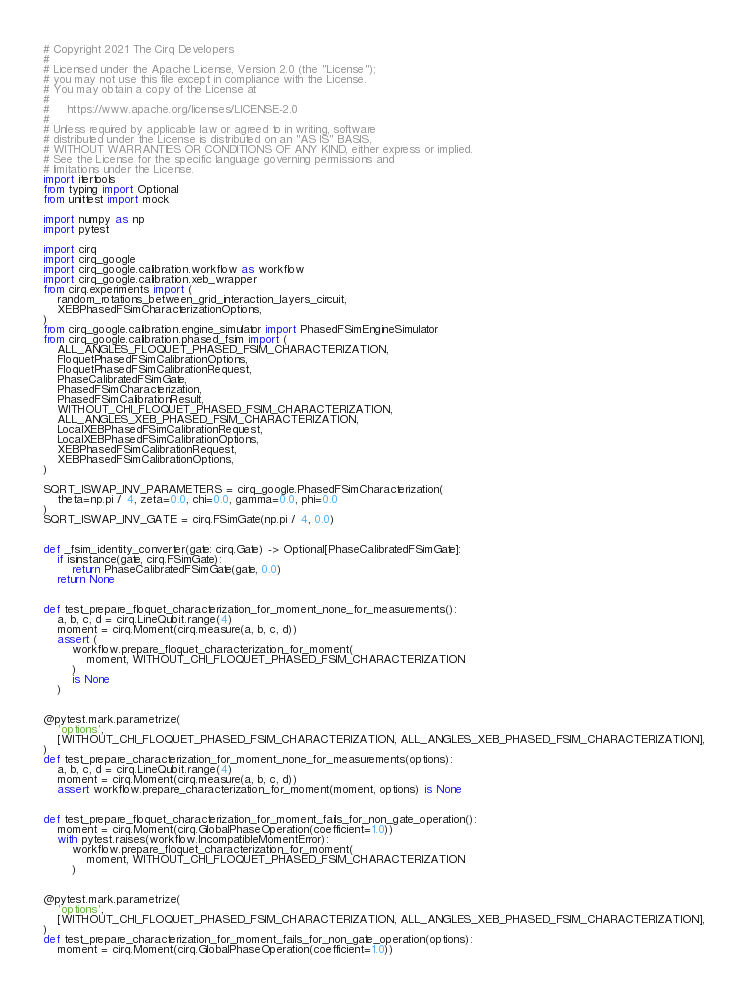Convert code to text. <code><loc_0><loc_0><loc_500><loc_500><_Python_># Copyright 2021 The Cirq Developers
#
# Licensed under the Apache License, Version 2.0 (the "License");
# you may not use this file except in compliance with the License.
# You may obtain a copy of the License at
#
#     https://www.apache.org/licenses/LICENSE-2.0
#
# Unless required by applicable law or agreed to in writing, software
# distributed under the License is distributed on an "AS IS" BASIS,
# WITHOUT WARRANTIES OR CONDITIONS OF ANY KIND, either express or implied.
# See the License for the specific language governing permissions and
# limitations under the License.
import itertools
from typing import Optional
from unittest import mock

import numpy as np
import pytest

import cirq
import cirq_google
import cirq_google.calibration.workflow as workflow
import cirq_google.calibration.xeb_wrapper
from cirq.experiments import (
    random_rotations_between_grid_interaction_layers_circuit,
    XEBPhasedFSimCharacterizationOptions,
)
from cirq_google.calibration.engine_simulator import PhasedFSimEngineSimulator
from cirq_google.calibration.phased_fsim import (
    ALL_ANGLES_FLOQUET_PHASED_FSIM_CHARACTERIZATION,
    FloquetPhasedFSimCalibrationOptions,
    FloquetPhasedFSimCalibrationRequest,
    PhaseCalibratedFSimGate,
    PhasedFSimCharacterization,
    PhasedFSimCalibrationResult,
    WITHOUT_CHI_FLOQUET_PHASED_FSIM_CHARACTERIZATION,
    ALL_ANGLES_XEB_PHASED_FSIM_CHARACTERIZATION,
    LocalXEBPhasedFSimCalibrationRequest,
    LocalXEBPhasedFSimCalibrationOptions,
    XEBPhasedFSimCalibrationRequest,
    XEBPhasedFSimCalibrationOptions,
)

SQRT_ISWAP_INV_PARAMETERS = cirq_google.PhasedFSimCharacterization(
    theta=np.pi / 4, zeta=0.0, chi=0.0, gamma=0.0, phi=0.0
)
SQRT_ISWAP_INV_GATE = cirq.FSimGate(np.pi / 4, 0.0)


def _fsim_identity_converter(gate: cirq.Gate) -> Optional[PhaseCalibratedFSimGate]:
    if isinstance(gate, cirq.FSimGate):
        return PhaseCalibratedFSimGate(gate, 0.0)
    return None


def test_prepare_floquet_characterization_for_moment_none_for_measurements():
    a, b, c, d = cirq.LineQubit.range(4)
    moment = cirq.Moment(cirq.measure(a, b, c, d))
    assert (
        workflow.prepare_floquet_characterization_for_moment(
            moment, WITHOUT_CHI_FLOQUET_PHASED_FSIM_CHARACTERIZATION
        )
        is None
    )


@pytest.mark.parametrize(
    'options',
    [WITHOUT_CHI_FLOQUET_PHASED_FSIM_CHARACTERIZATION, ALL_ANGLES_XEB_PHASED_FSIM_CHARACTERIZATION],
)
def test_prepare_characterization_for_moment_none_for_measurements(options):
    a, b, c, d = cirq.LineQubit.range(4)
    moment = cirq.Moment(cirq.measure(a, b, c, d))
    assert workflow.prepare_characterization_for_moment(moment, options) is None


def test_prepare_floquet_characterization_for_moment_fails_for_non_gate_operation():
    moment = cirq.Moment(cirq.GlobalPhaseOperation(coefficient=1.0))
    with pytest.raises(workflow.IncompatibleMomentError):
        workflow.prepare_floquet_characterization_for_moment(
            moment, WITHOUT_CHI_FLOQUET_PHASED_FSIM_CHARACTERIZATION
        )


@pytest.mark.parametrize(
    'options',
    [WITHOUT_CHI_FLOQUET_PHASED_FSIM_CHARACTERIZATION, ALL_ANGLES_XEB_PHASED_FSIM_CHARACTERIZATION],
)
def test_prepare_characterization_for_moment_fails_for_non_gate_operation(options):
    moment = cirq.Moment(cirq.GlobalPhaseOperation(coefficient=1.0))</code> 